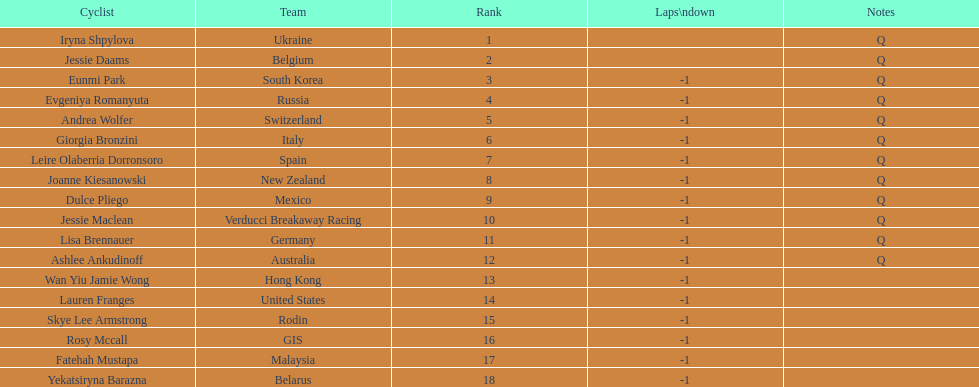Who was the competitor that finished above jessie maclean? Dulce Pliego. 